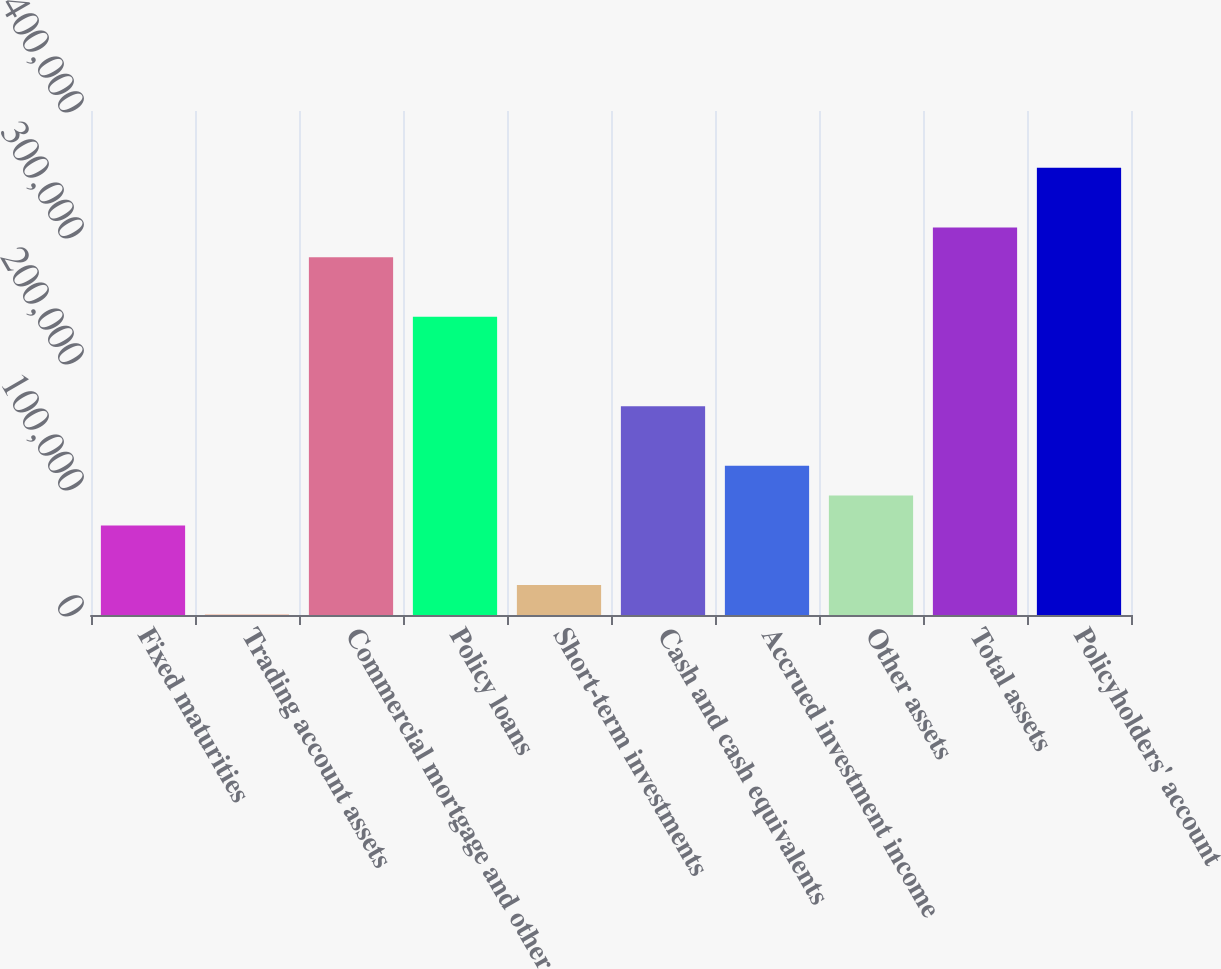Convert chart. <chart><loc_0><loc_0><loc_500><loc_500><bar_chart><fcel>Fixed maturities<fcel>Trading account assets<fcel>Commercial mortgage and other<fcel>Policy loans<fcel>Short-term investments<fcel>Cash and cash equivalents<fcel>Accrued investment income<fcel>Other assets<fcel>Total assets<fcel>Policyholders' account<nl><fcel>71101.8<fcel>150<fcel>283957<fcel>236656<fcel>23800.6<fcel>165704<fcel>118403<fcel>94752.4<fcel>307608<fcel>354909<nl></chart> 